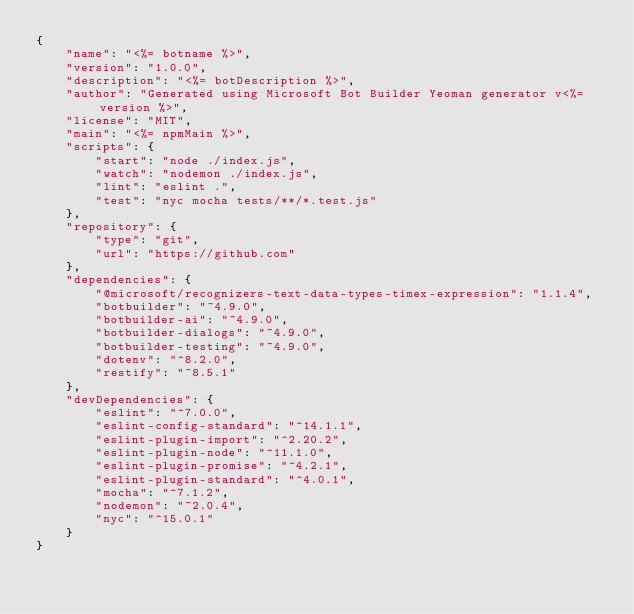<code> <loc_0><loc_0><loc_500><loc_500><_JavaScript_>{
    "name": "<%= botname %>",
    "version": "1.0.0",
    "description": "<%= botDescription %>",
    "author": "Generated using Microsoft Bot Builder Yeoman generator v<%= version %>",
    "license": "MIT",
    "main": "<%= npmMain %>",
    "scripts": {
        "start": "node ./index.js",
        "watch": "nodemon ./index.js",
        "lint": "eslint .",
        "test": "nyc mocha tests/**/*.test.js"
    },
    "repository": {
        "type": "git",
        "url": "https://github.com"
    },
    "dependencies": {
        "@microsoft/recognizers-text-data-types-timex-expression": "1.1.4",
        "botbuilder": "~4.9.0",
        "botbuilder-ai": "~4.9.0",
        "botbuilder-dialogs": "~4.9.0",
        "botbuilder-testing": "~4.9.0",
        "dotenv": "^8.2.0",
        "restify": "~8.5.1"
    },
    "devDependencies": {
        "eslint": "^7.0.0",
        "eslint-config-standard": "^14.1.1",
        "eslint-plugin-import": "^2.20.2",
        "eslint-plugin-node": "^11.1.0",
        "eslint-plugin-promise": "^4.2.1",
        "eslint-plugin-standard": "^4.0.1",
        "mocha": "^7.1.2",
        "nodemon": "~2.0.4",
        "nyc": "^15.0.1"
    }
}
</code> 